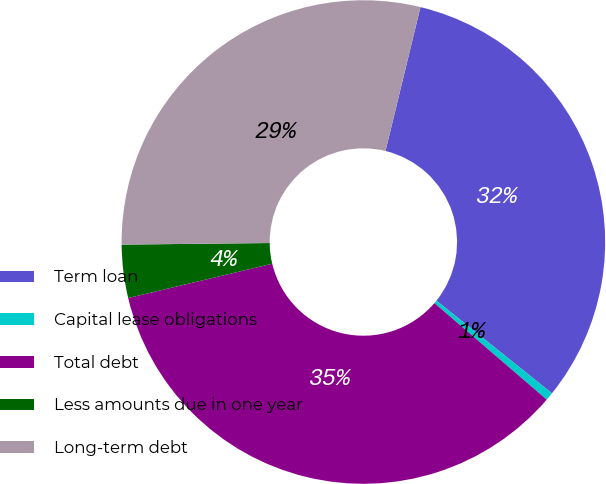<chart> <loc_0><loc_0><loc_500><loc_500><pie_chart><fcel>Term loan<fcel>Capital lease obligations<fcel>Total debt<fcel>Less amounts due in one year<fcel>Long-term debt<nl><fcel>31.97%<fcel>0.54%<fcel>34.98%<fcel>3.55%<fcel>28.97%<nl></chart> 